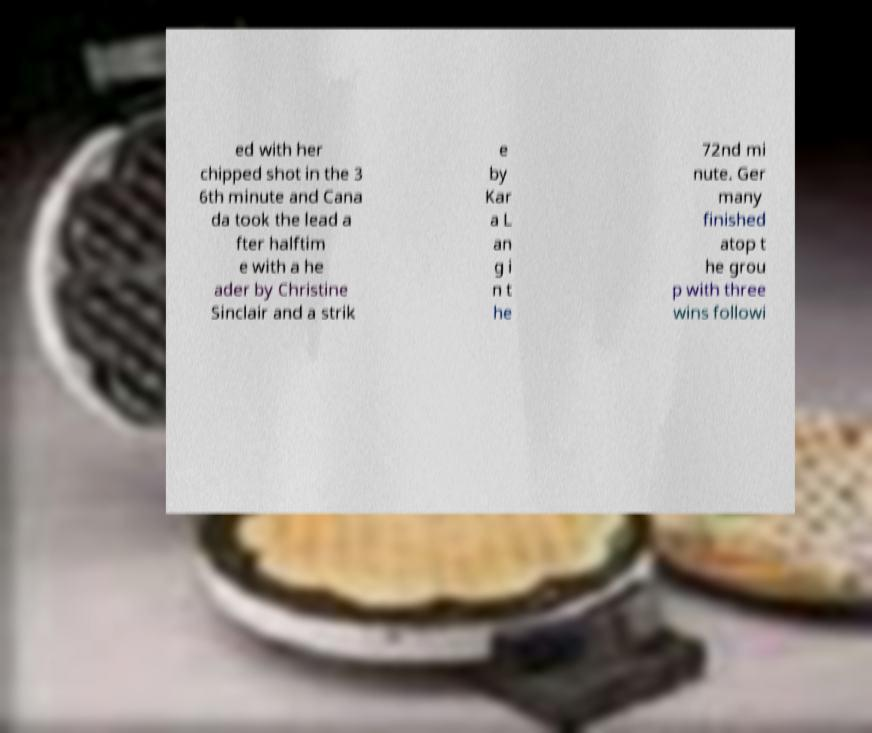I need the written content from this picture converted into text. Can you do that? ed with her chipped shot in the 3 6th minute and Cana da took the lead a fter halftim e with a he ader by Christine Sinclair and a strik e by Kar a L an g i n t he 72nd mi nute. Ger many finished atop t he grou p with three wins followi 